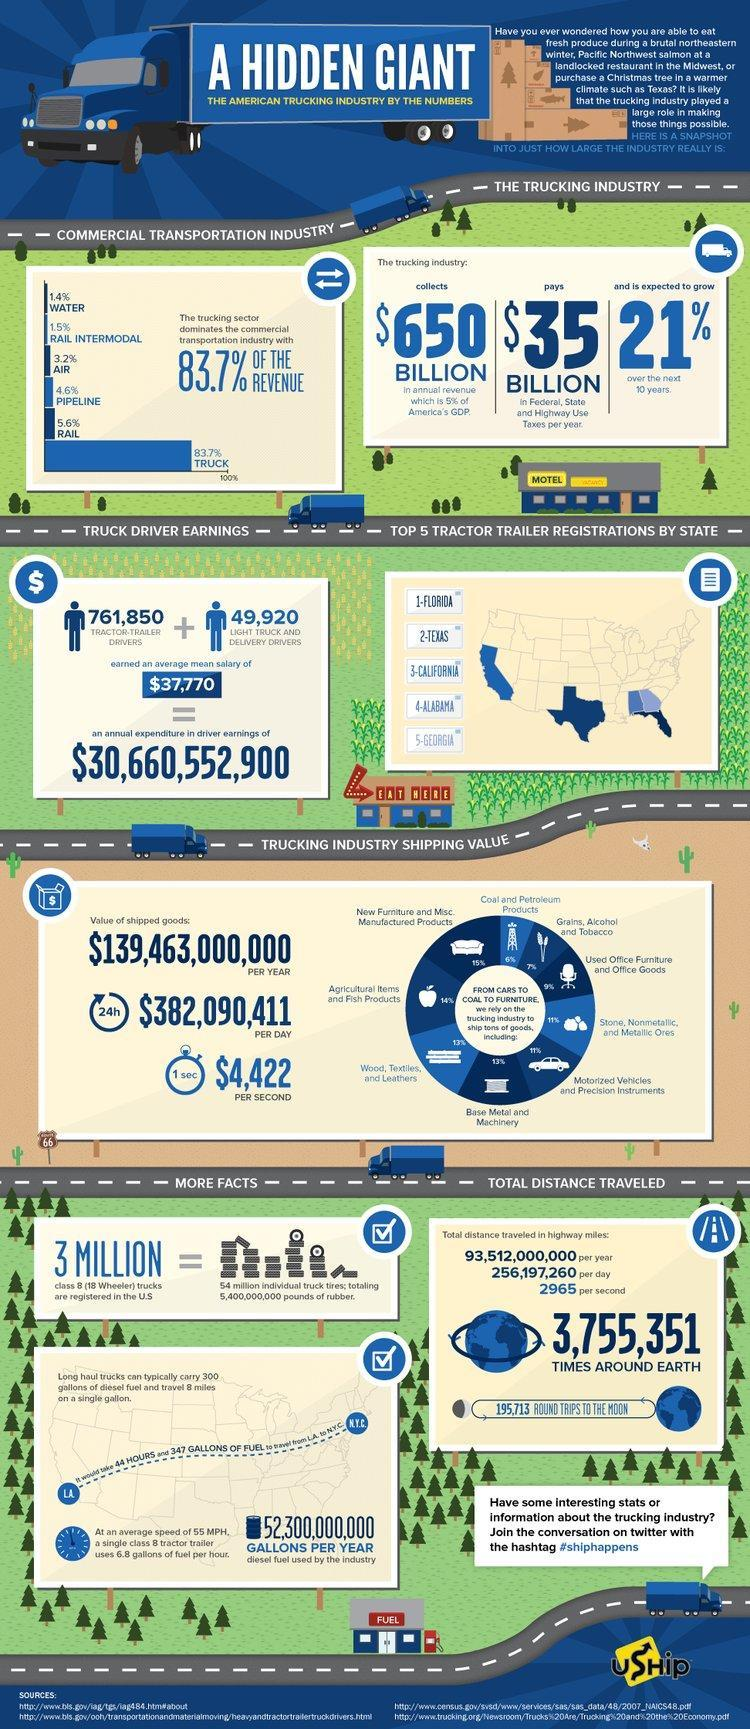What constitutes the most shipped Goods?
Answer the question with a short phrase. New Furniture and Misc. Manufactured Products What is 5% of America's GDP? $650 Billion What is the second most shipped product? Agriculture Items and Fish Products What is the percentage of Wood, Textiles and Leathers in total shipped goods? 13% What percentage of shipments constitutes the Base Metal and machinery? 13% What is the percentage of Coal and Petroleum products in total shipped goods? 6% What is the value of shipped goods per second? $4,422 What is the second least shipped product? Grains, Alcohol and Tobacco What product constitutes the least percentage in shipped products? Coal and Petroleum products What is the value of shipped goods per Year? $139,463,000,000 What is the percentage of Grains, Alcohol and Tobacco in total shipped goods? 7% What is the value of shipped goods per day? $382,090,411 